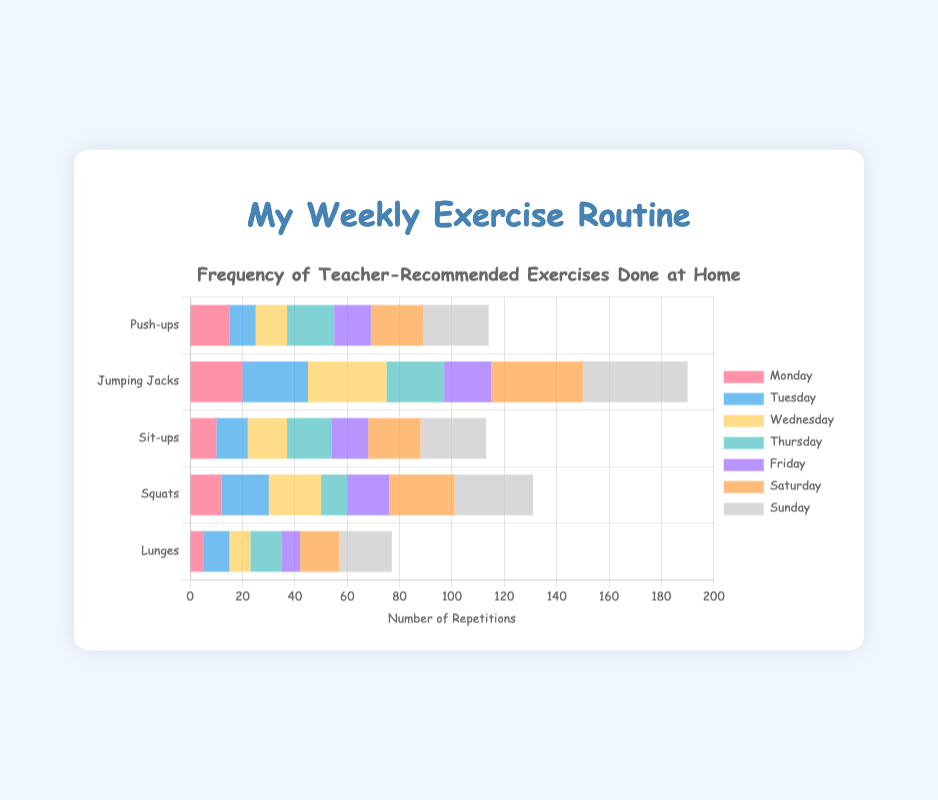what exercise has the highest frequency on Wednesday? To find the exercise with the highest frequency on Wednesday, look at the bars labeled 'Wednesday' and compare their lengths. Jumping Jacks have the highest frequency at 30.
Answer: Jumping Jacks Compare the number of Push-ups done on Monday and Sunday. Which day has more? To compare, look at the bars for Push-ups on Monday and Sunday. The bar for Sunday is 25, and the bar for Monday is 15. Sunday has more Push-ups.
Answer: Sunday What's the total number of Lunges done from Monday to Sunday? To find the total, add up the numbers for Lunges for each day: 5 (Mon) + 10 (Tue) + 8 (Wed) + 12 (Thu) + 7 (Fri) + 15 (Sat) + 20 (Sun) = 77.
Answer: 77 Which exercise saw an equal number of reps on Wednesday and Friday? Compare the bars for Wednesday and Friday for each exercise. Sit-ups have equal numbers on both days at 15 and 14, respectively. No exercise has equal counts.
Answer: None Compare the frequencies of Squats done on Tuesday and Thursday. Which day has more? Look at the bars for Squats on Tuesday and Thursday. The bar for Tuesday is 18, and the bar for Thursday is 10. Tuesday has more Squats.
Answer: Tuesday How many more Jumping Jacks were done on Saturday than on Monday? Compare the bars for Jumping Jacks on Saturday and Monday and subtract Monday's frequency from Saturday's: 35 - 20 = 15.
Answer: 15 What's the average number of Sit-ups done on Tuesday and Wednesday? Add the numbers for Sit-ups on Tuesday and Wednesday and divide by 2: (12 + 15) / 2 = 27 / 2 = 13.5.
Answer: 13.5 Which day had the highest total number of exercises done? Sum the frequencies for each exercise on each day and compare. Sunday: 25 + 40 + 25 + 30 + 20 = 140, it's the highest.
Answer: Sunday 